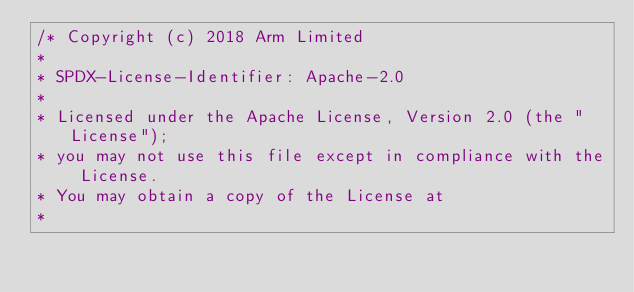<code> <loc_0><loc_0><loc_500><loc_500><_C++_>/* Copyright (c) 2018 Arm Limited
*
* SPDX-License-Identifier: Apache-2.0
*
* Licensed under the Apache License, Version 2.0 (the "License");
* you may not use this file except in compliance with the License.
* You may obtain a copy of the License at
*</code> 